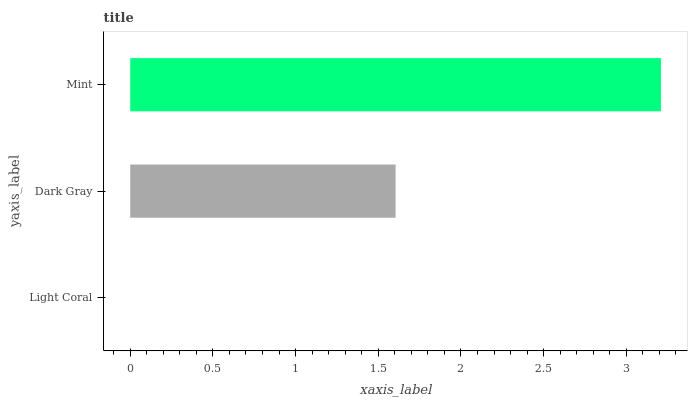Is Light Coral the minimum?
Answer yes or no. Yes. Is Mint the maximum?
Answer yes or no. Yes. Is Dark Gray the minimum?
Answer yes or no. No. Is Dark Gray the maximum?
Answer yes or no. No. Is Dark Gray greater than Light Coral?
Answer yes or no. Yes. Is Light Coral less than Dark Gray?
Answer yes or no. Yes. Is Light Coral greater than Dark Gray?
Answer yes or no. No. Is Dark Gray less than Light Coral?
Answer yes or no. No. Is Dark Gray the high median?
Answer yes or no. Yes. Is Dark Gray the low median?
Answer yes or no. Yes. Is Mint the high median?
Answer yes or no. No. Is Light Coral the low median?
Answer yes or no. No. 